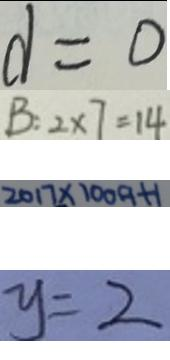Convert formula to latex. <formula><loc_0><loc_0><loc_500><loc_500>d = 0 
 B : 2 \times 7 = 1 4 
 2 0 1 7 \times 1 0 0 9 + 1 
 y = 2</formula> 